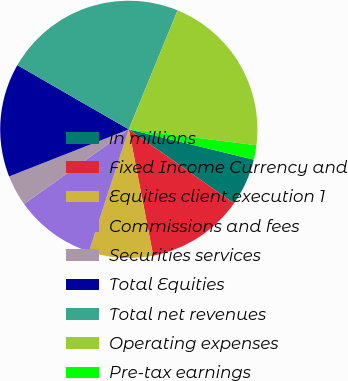Convert chart to OTSL. <chart><loc_0><loc_0><loc_500><loc_500><pie_chart><fcel>in millions<fcel>Fixed Income Currency and<fcel>Equities client execution 1<fcel>Commissions and fees<fcel>Securities services<fcel>Total Equities<fcel>Total net revenues<fcel>Operating expenses<fcel>Pre-tax earnings<nl><fcel>5.97%<fcel>12.21%<fcel>8.05%<fcel>10.13%<fcel>3.89%<fcel>14.29%<fcel>22.87%<fcel>20.79%<fcel>1.81%<nl></chart> 